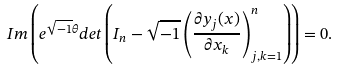<formula> <loc_0><loc_0><loc_500><loc_500>I m \left ( e ^ { \sqrt { - 1 } \theta } d e t \left ( I _ { n } - \sqrt { - 1 } \left ( \frac { \partial y _ { j } ( x ) } { \partial x _ { k } } \right ) _ { j , k = 1 } ^ { n } \right ) \right ) = 0 .</formula> 